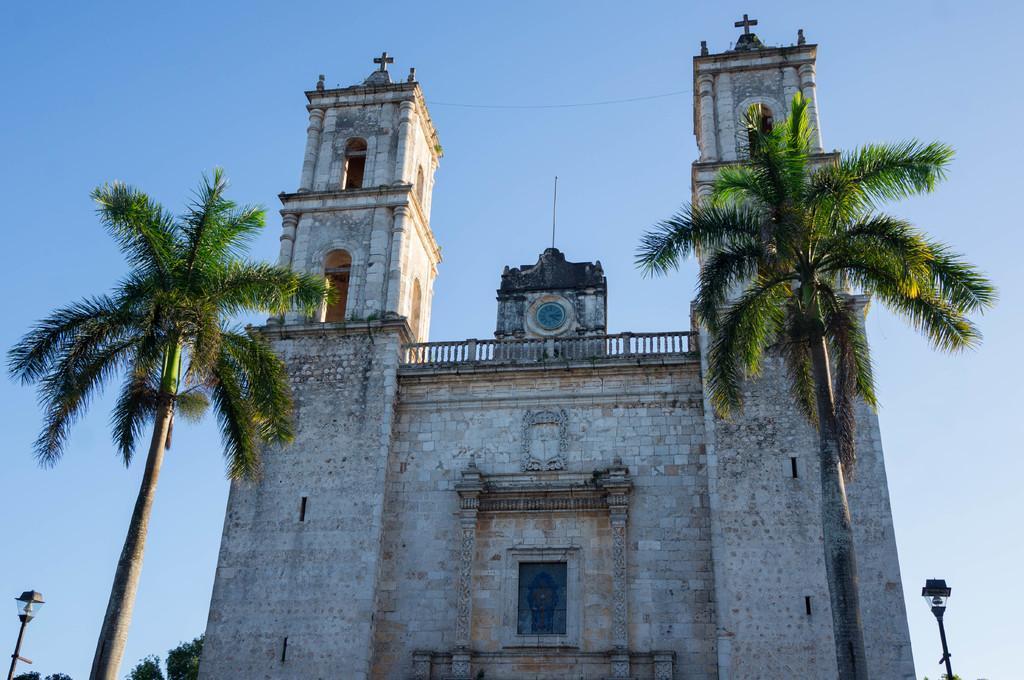Please provide a concise description of this image. In this image it seems like it is a church in the middle. There are two trees on either side of the church. On the left side bottom there is a light. On the right side bottom there is another light. At the top there is the sky. 